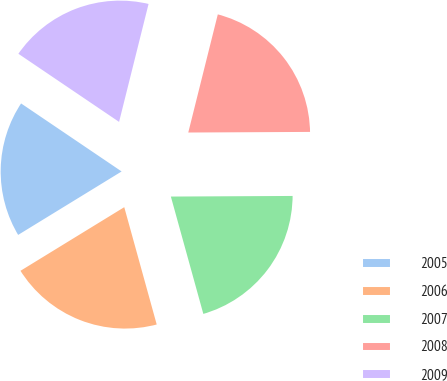Convert chart to OTSL. <chart><loc_0><loc_0><loc_500><loc_500><pie_chart><fcel>2005<fcel>2006<fcel>2007<fcel>2008<fcel>2009<nl><fcel>18.22%<fcel>20.54%<fcel>20.78%<fcel>21.02%<fcel>19.43%<nl></chart> 